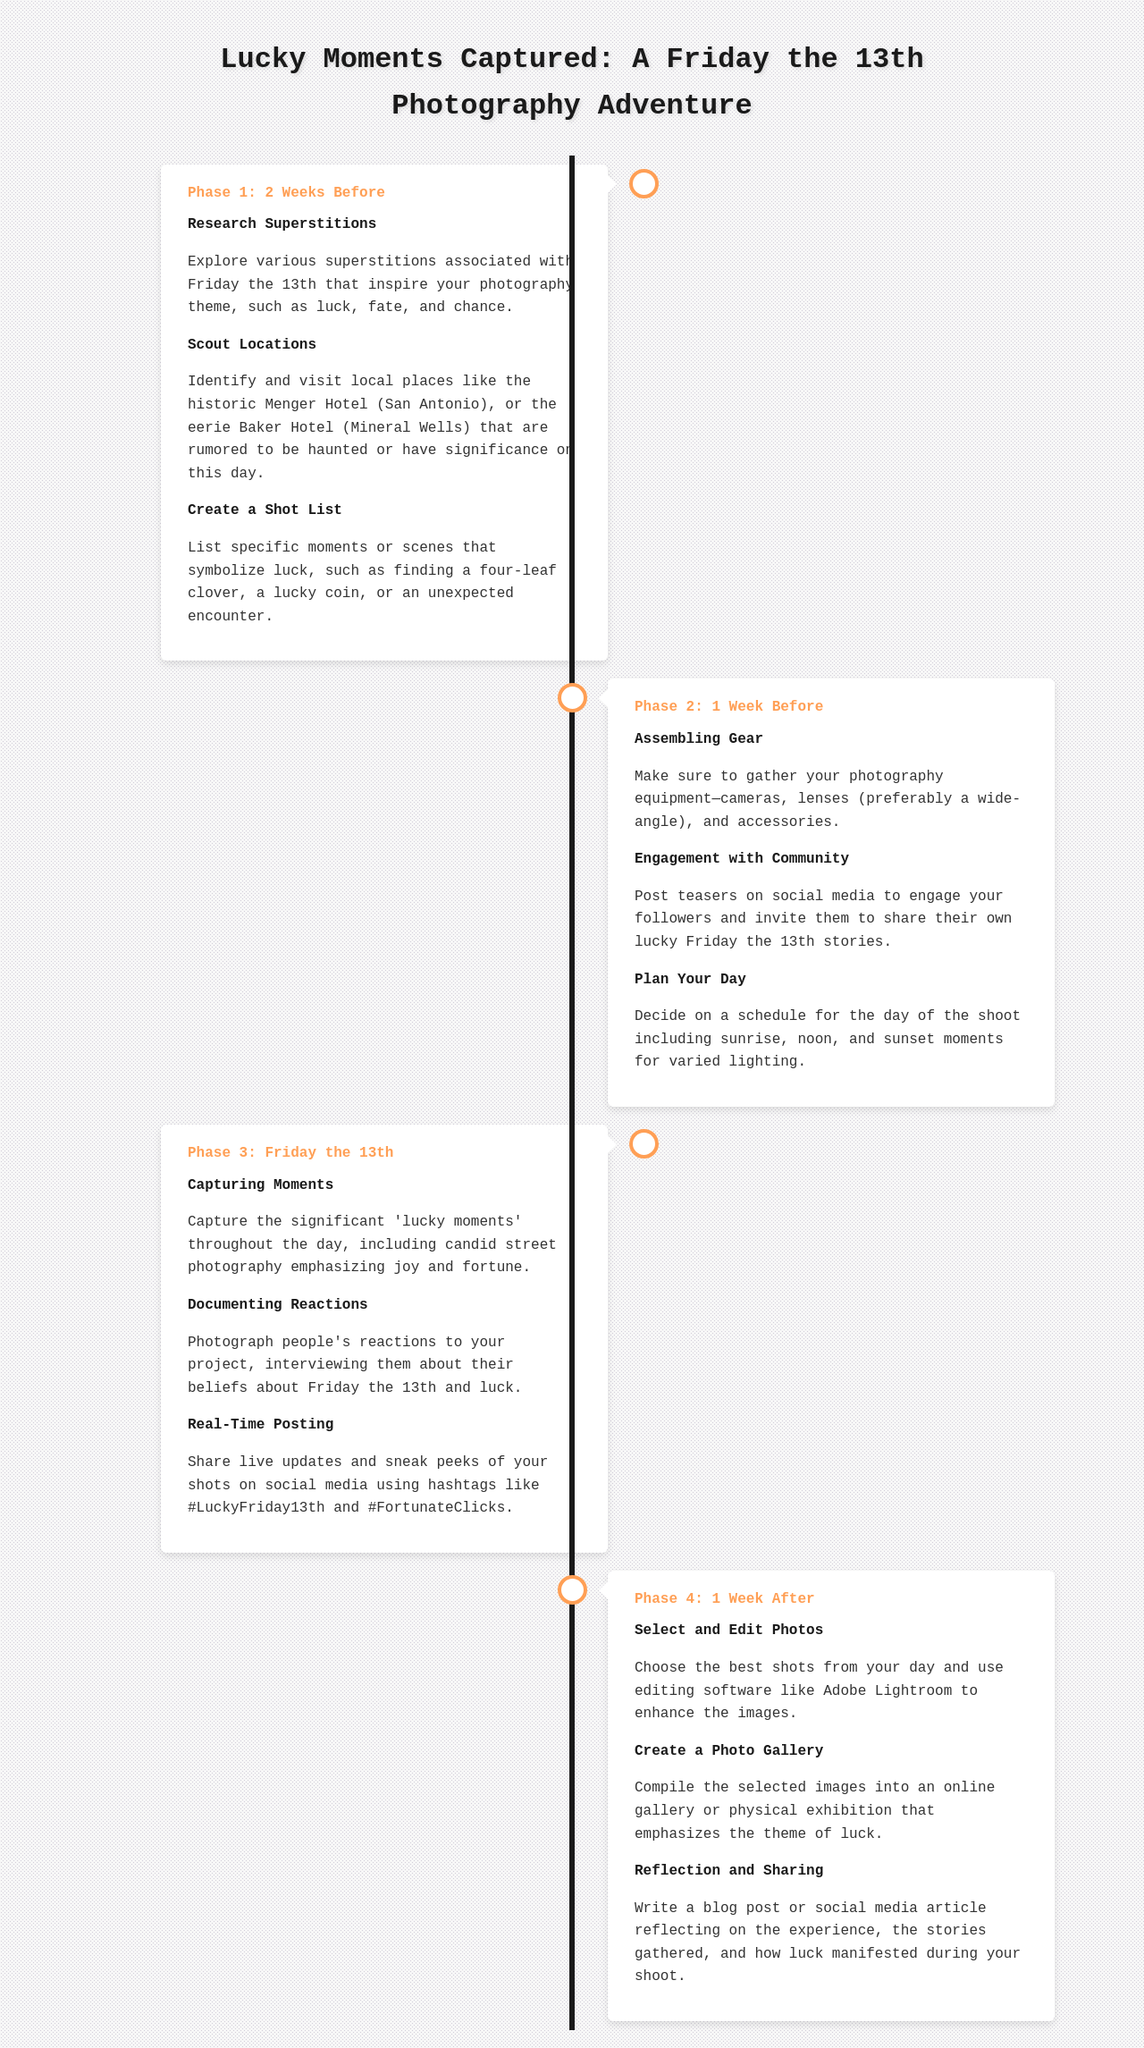What is the title of the photography project? The title is mentioned at the top of the document as the main heading.
Answer: Lucky Moments Captured: A Friday the 13th Photography Adventure How many phases are outlined in the timeline? The document describes four distinct phases in the photography project timeline.
Answer: 4 What is the first task in Phase 1? The first task is listed in the Phase 1 section and is focused on superstitions.
Answer: Research Superstitions What type of lens is preferred for assembling gear? The preference for lens type is directly mentioned in the relevant task within Phase 2.
Answer: Wide-angle During which phase is capturing moments planned? The phase in which capturing moments occurs is highlighted as Phase 3.
Answer: Phase 3 What social media hashtags are suggested for real-time posting? The hashtags are specifically mentioned during the task in Phase 3 about sharing updates.
Answer: #LuckyFriday13th and #FortunateClicks What is the last task in Phase 4? The last task in Phase 4 is the final step in the project timeline, which relates to sharing experiences.
Answer: Reflection and Sharing When does the project start according to the schedule? The starting point for the project is indicated by the first phase, which is two weeks prior to the main event.
Answer: 2 Weeks Before 